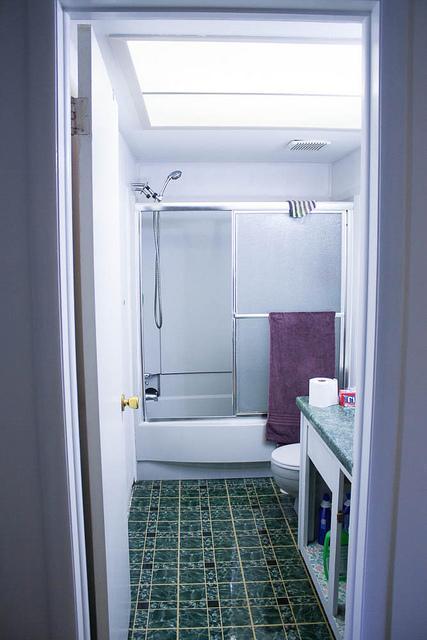How many towels are on the road?
Give a very brief answer. 1. 